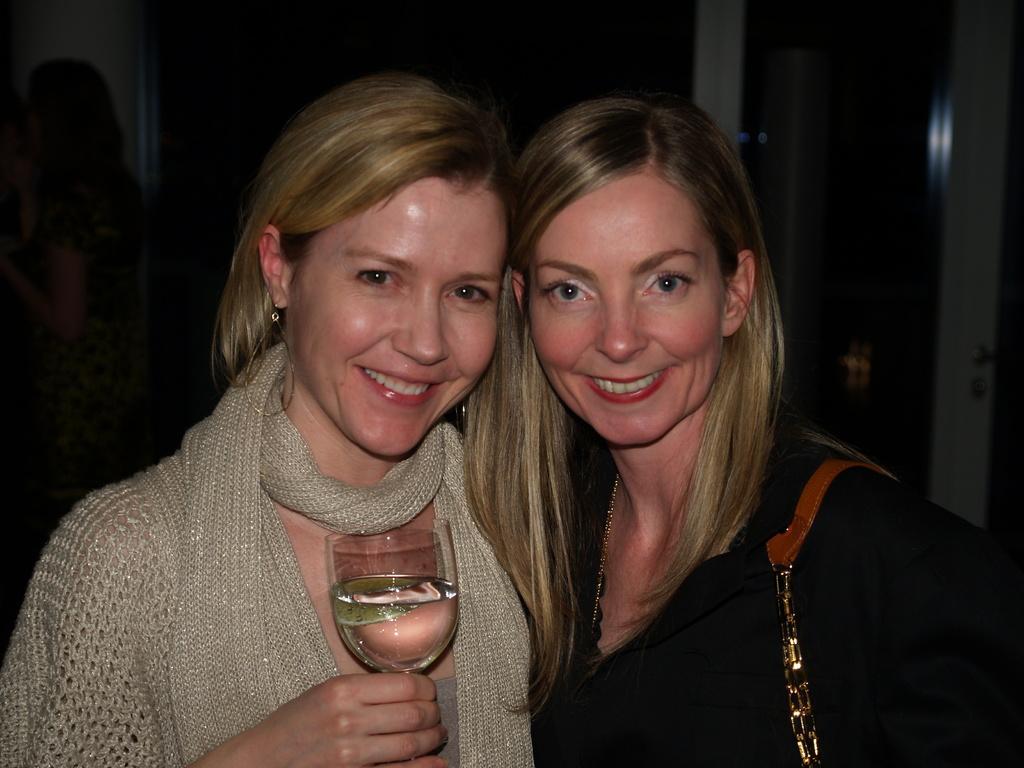How would you summarize this image in a sentence or two? In the image there are two women standing. On left side there is a woman wearing a scarf holding a wine glass on her hand and she is also having smile on her face. In background we can see a person and a wall. 